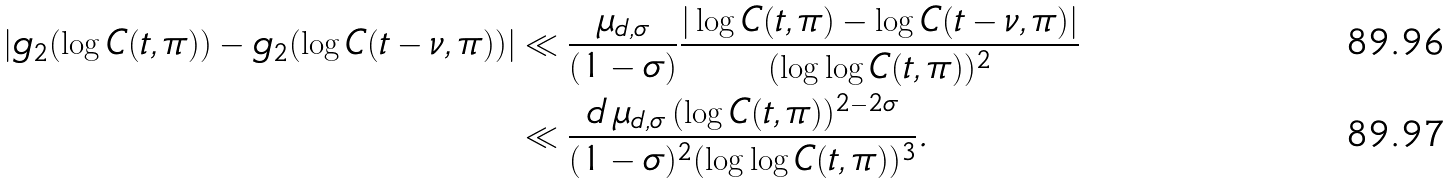<formula> <loc_0><loc_0><loc_500><loc_500>\left | g _ { 2 } ( \log C ( t , \pi ) ) - g _ { 2 } ( \log C ( t - \nu , \pi ) ) \right | & \ll \frac { \mu _ { d , \sigma } } { ( 1 - \sigma ) } \frac { | \log C ( t , \pi ) - \log C ( t - \nu , \pi ) | } { ( \log \log C ( t , \pi ) ) ^ { 2 } } \\ & \ll \frac { d \, \mu _ { d , \sigma } \, ( \log C ( t , \pi ) ) ^ { 2 - 2 \sigma } } { ( 1 - \sigma ) ^ { 2 } ( \log \log C ( t , \pi ) ) ^ { 3 } } .</formula> 